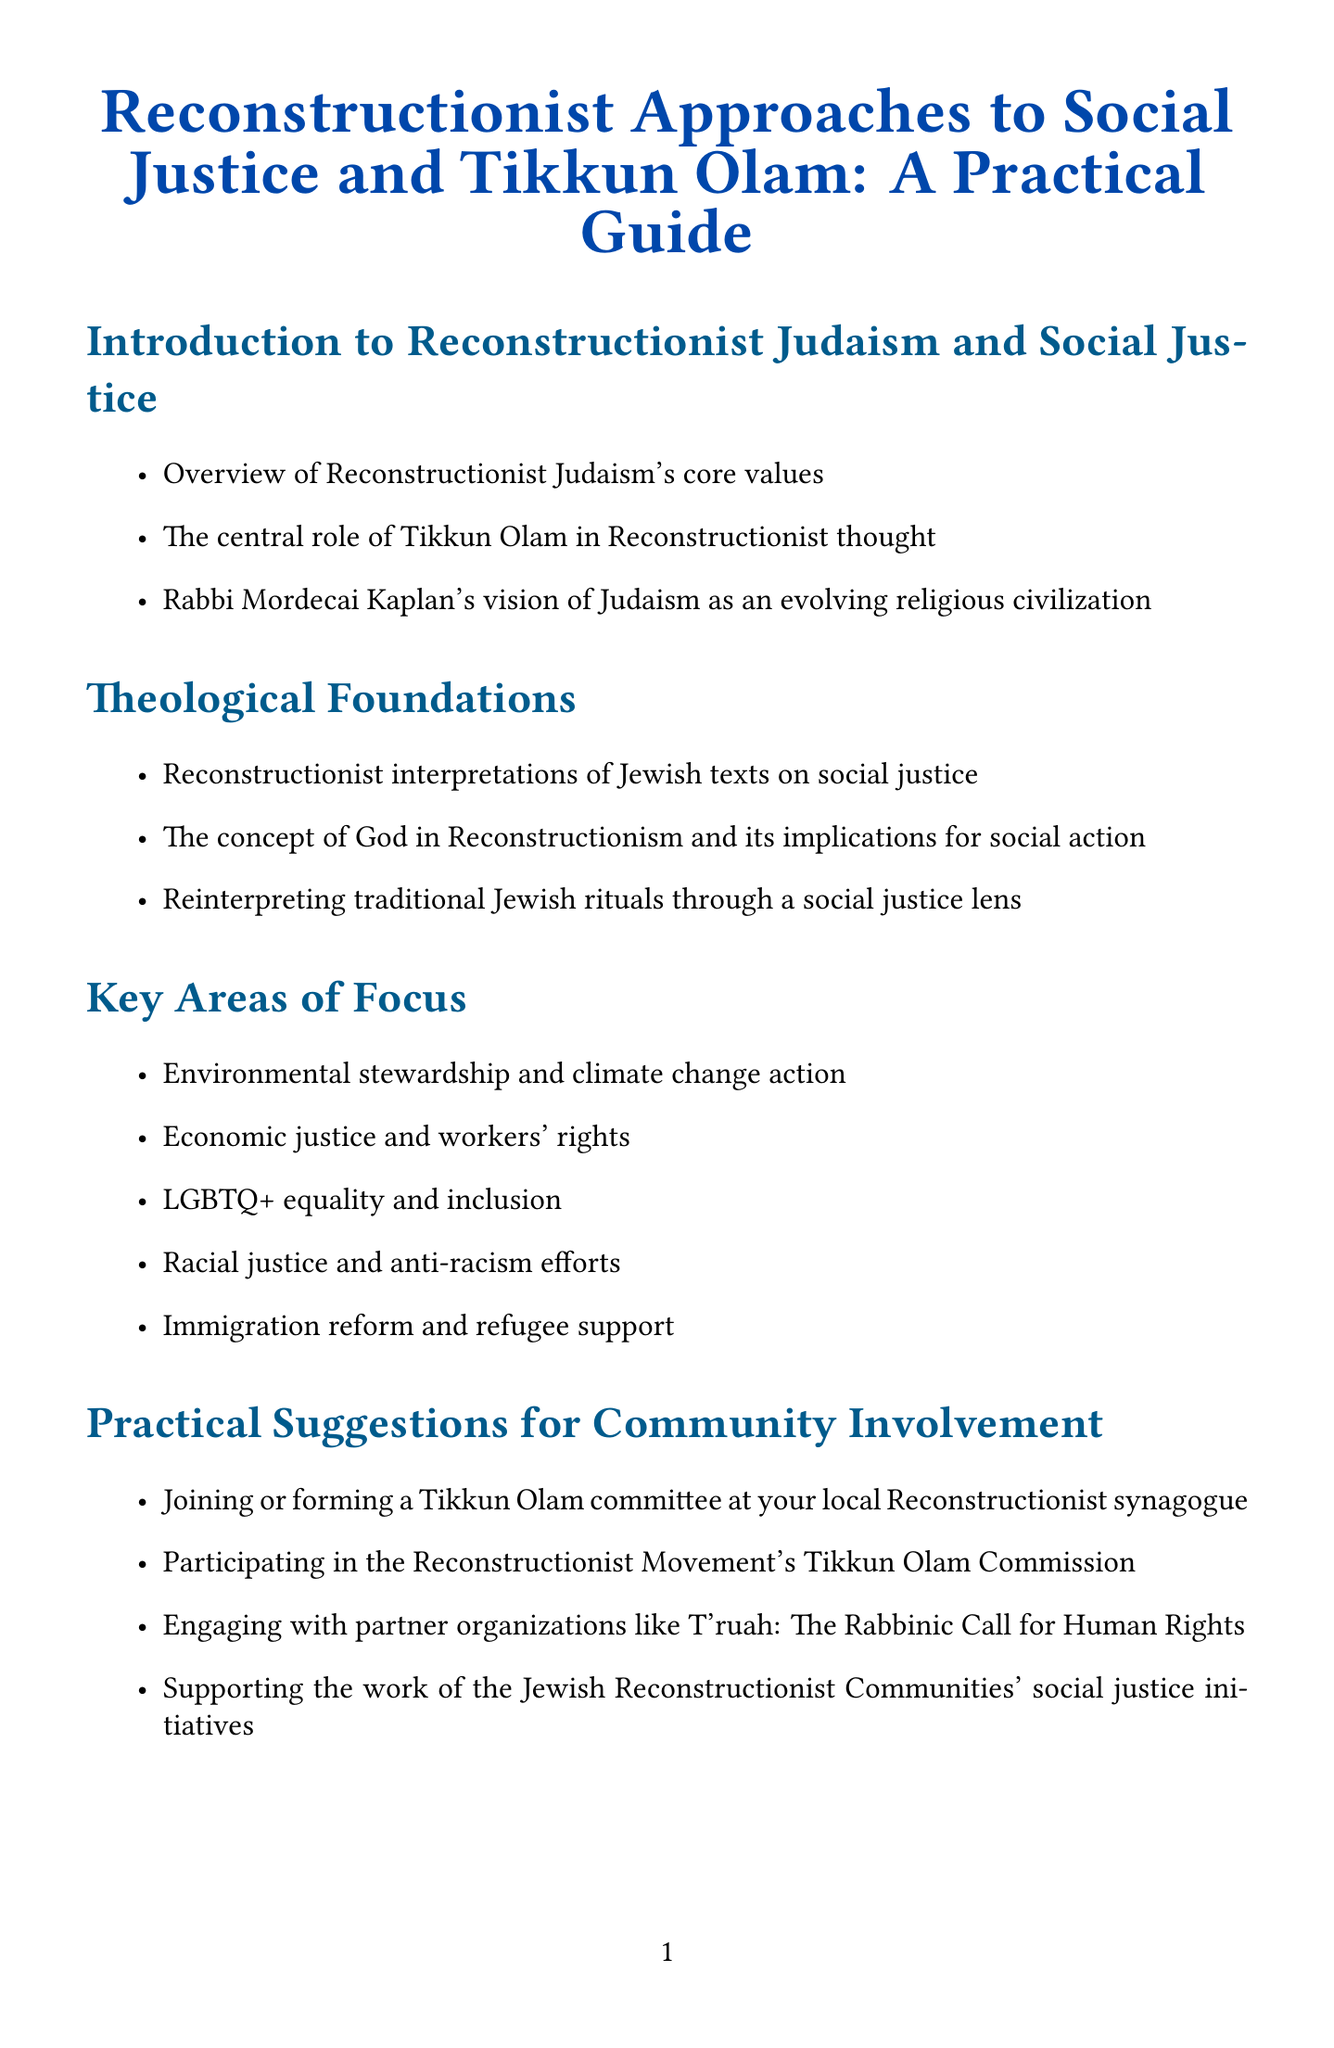What is the title of the guide? The title of the guide is provided in the document's header.
Answer: Reconstructionist Approaches to Social Justice and Tikkun Olam: A Practical Guide Who is the author of the quoted book on justice? The author of the book mentioned in the resources section is the only one specified.
Answer: Rabbi Sidney Schwarz What are two key areas of focus in the guide? The key areas of focus are outlined in a list format.
Answer: Environmental stewardship and economic justice Name one practical suggestion for community involvement. The document lists practical suggestions for engaging in community activities.
Answer: Joining or forming a Tikkun Olam committee What is Rabbi Mordecai Kaplan's vision described as? The vision articulated in the introduction encapsulates a broader understanding of Judaism.
Answer: An evolving religious civilization How many case studies are presented in the document? The section titled "Case Studies" enumerates the instances provided.
Answer: Three What type of strategies are discussed in the activism section? The strategies are categorized and described under a specific heading.
Answer: Organizing community education events What theme is suggested for journaling exercises? The reflections section indicates areas for personal introspection and goals.
Answer: Personal social justice goals 